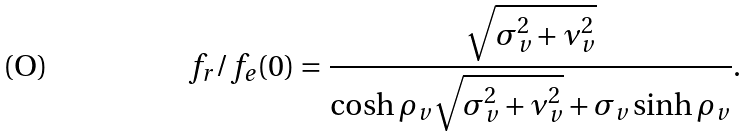<formula> <loc_0><loc_0><loc_500><loc_500>f _ { r } / f _ { e } ( 0 ) = \frac { \sqrt { \sigma _ { v } ^ { 2 } + \nu _ { v } ^ { 2 } } } { \cosh \rho _ { v } \sqrt { \sigma _ { v } ^ { 2 } + \nu _ { v } ^ { 2 } } + \sigma _ { v } \sinh \rho _ { v } } .</formula> 